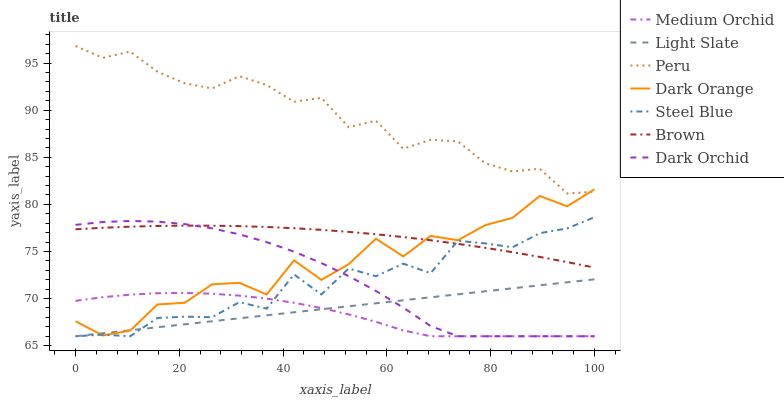Does Medium Orchid have the minimum area under the curve?
Answer yes or no. Yes. Does Brown have the minimum area under the curve?
Answer yes or no. No. Does Brown have the maximum area under the curve?
Answer yes or no. No. Is Brown the smoothest?
Answer yes or no. No. Is Brown the roughest?
Answer yes or no. No. Does Brown have the lowest value?
Answer yes or no. No. Does Brown have the highest value?
Answer yes or no. No. Is Dark Orchid less than Peru?
Answer yes or no. Yes. Is Brown greater than Light Slate?
Answer yes or no. Yes. Does Dark Orchid intersect Peru?
Answer yes or no. No. 